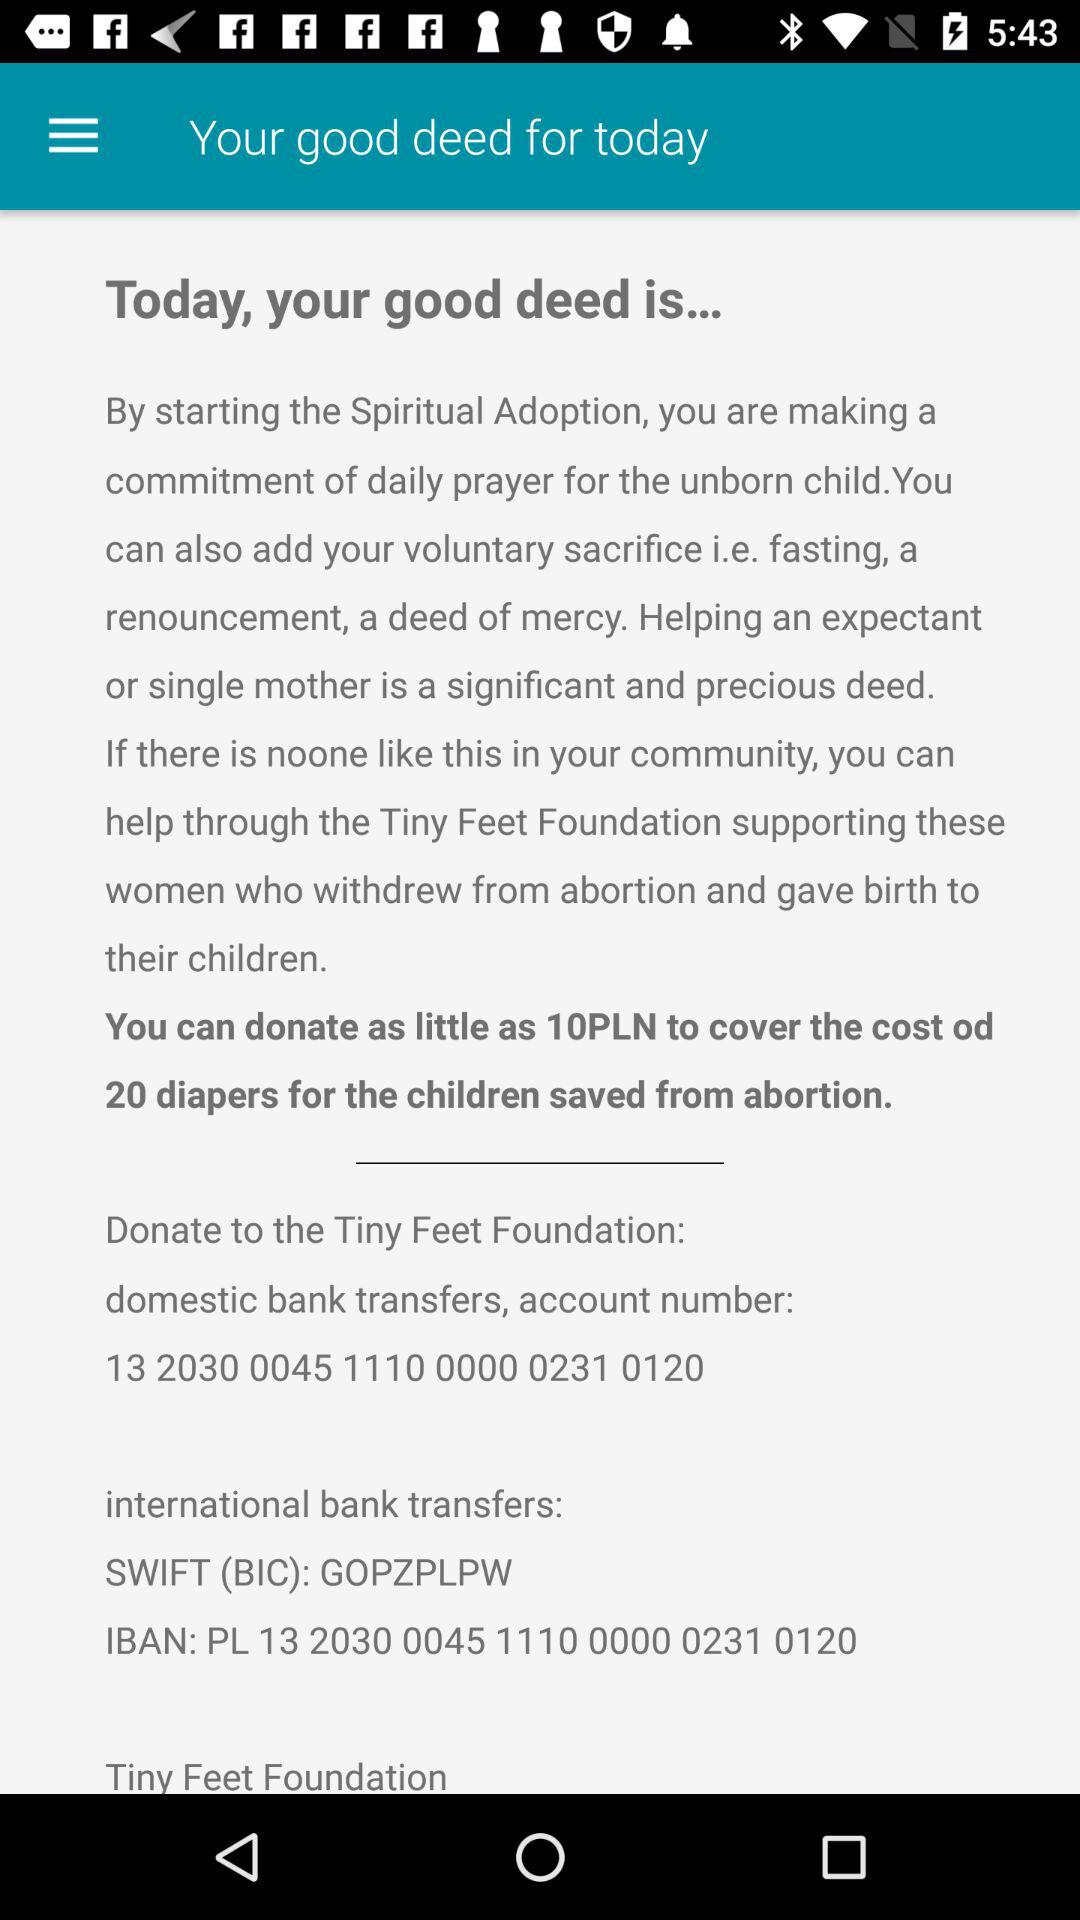What is the account number? The account number is 13 2030 0045 1110 0000 0231 0120. 